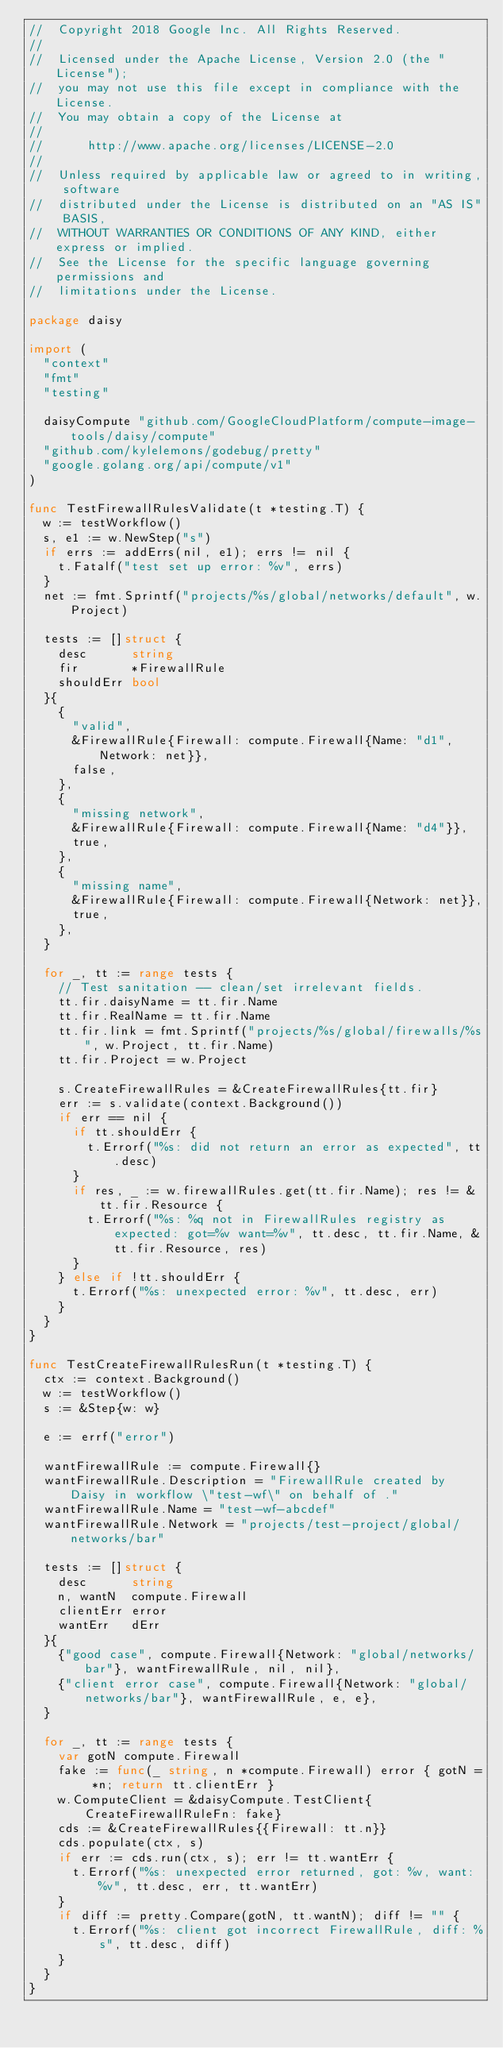<code> <loc_0><loc_0><loc_500><loc_500><_Go_>//  Copyright 2018 Google Inc. All Rights Reserved.
//
//  Licensed under the Apache License, Version 2.0 (the "License");
//  you may not use this file except in compliance with the License.
//  You may obtain a copy of the License at
//
//      http://www.apache.org/licenses/LICENSE-2.0
//
//  Unless required by applicable law or agreed to in writing, software
//  distributed under the License is distributed on an "AS IS" BASIS,
//  WITHOUT WARRANTIES OR CONDITIONS OF ANY KIND, either express or implied.
//  See the License for the specific language governing permissions and
//  limitations under the License.

package daisy

import (
	"context"
	"fmt"
	"testing"

	daisyCompute "github.com/GoogleCloudPlatform/compute-image-tools/daisy/compute"
	"github.com/kylelemons/godebug/pretty"
	"google.golang.org/api/compute/v1"
)

func TestFirewallRulesValidate(t *testing.T) {
	w := testWorkflow()
	s, e1 := w.NewStep("s")
	if errs := addErrs(nil, e1); errs != nil {
		t.Fatalf("test set up error: %v", errs)
	}
	net := fmt.Sprintf("projects/%s/global/networks/default", w.Project)

	tests := []struct {
		desc      string
		fir       *FirewallRule
		shouldErr bool
	}{
		{
			"valid",
			&FirewallRule{Firewall: compute.Firewall{Name: "d1", Network: net}},
			false,
		},
		{
			"missing network",
			&FirewallRule{Firewall: compute.Firewall{Name: "d4"}},
			true,
		},
		{
			"missing name",
			&FirewallRule{Firewall: compute.Firewall{Network: net}},
			true,
		},
	}

	for _, tt := range tests {
		// Test sanitation -- clean/set irrelevant fields.
		tt.fir.daisyName = tt.fir.Name
		tt.fir.RealName = tt.fir.Name
		tt.fir.link = fmt.Sprintf("projects/%s/global/firewalls/%s", w.Project, tt.fir.Name)
		tt.fir.Project = w.Project

		s.CreateFirewallRules = &CreateFirewallRules{tt.fir}
		err := s.validate(context.Background())
		if err == nil {
			if tt.shouldErr {
				t.Errorf("%s: did not return an error as expected", tt.desc)
			}
			if res, _ := w.firewallRules.get(tt.fir.Name); res != &tt.fir.Resource {
				t.Errorf("%s: %q not in FirewallRules registry as expected: got=%v want=%v", tt.desc, tt.fir.Name, &tt.fir.Resource, res)
			}
		} else if !tt.shouldErr {
			t.Errorf("%s: unexpected error: %v", tt.desc, err)
		}
	}
}

func TestCreateFirewallRulesRun(t *testing.T) {
	ctx := context.Background()
	w := testWorkflow()
	s := &Step{w: w}

	e := errf("error")

	wantFirewallRule := compute.Firewall{}
	wantFirewallRule.Description = "FirewallRule created by Daisy in workflow \"test-wf\" on behalf of ."
	wantFirewallRule.Name = "test-wf-abcdef"
	wantFirewallRule.Network = "projects/test-project/global/networks/bar"

	tests := []struct {
		desc      string
		n, wantN  compute.Firewall
		clientErr error
		wantErr   dErr
	}{
		{"good case", compute.Firewall{Network: "global/networks/bar"}, wantFirewallRule, nil, nil},
		{"client error case", compute.Firewall{Network: "global/networks/bar"}, wantFirewallRule, e, e},
	}

	for _, tt := range tests {
		var gotN compute.Firewall
		fake := func(_ string, n *compute.Firewall) error { gotN = *n; return tt.clientErr }
		w.ComputeClient = &daisyCompute.TestClient{CreateFirewallRuleFn: fake}
		cds := &CreateFirewallRules{{Firewall: tt.n}}
		cds.populate(ctx, s)
		if err := cds.run(ctx, s); err != tt.wantErr {
			t.Errorf("%s: unexpected error returned, got: %v, want: %v", tt.desc, err, tt.wantErr)
		}
		if diff := pretty.Compare(gotN, tt.wantN); diff != "" {
			t.Errorf("%s: client got incorrect FirewallRule, diff: %s", tt.desc, diff)
		}
	}
}
</code> 